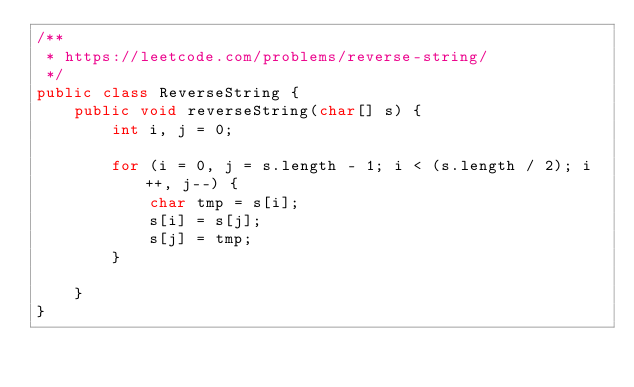Convert code to text. <code><loc_0><loc_0><loc_500><loc_500><_Java_>/**
 * https://leetcode.com/problems/reverse-string/
 */
public class ReverseString {
    public void reverseString(char[] s) {
        int i, j = 0;

        for (i = 0, j = s.length - 1; i < (s.length / 2); i++, j--) {
            char tmp = s[i];
            s[i] = s[j];
            s[j] = tmp;
        }

    }
}
</code> 